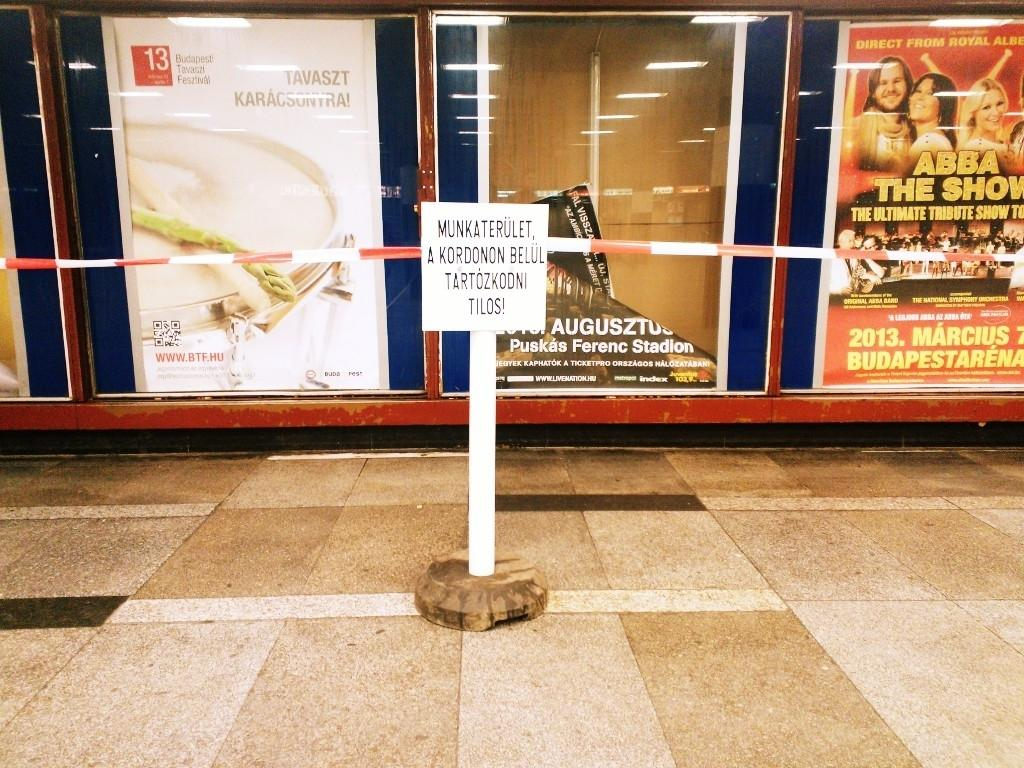<image>
Give a short and clear explanation of the subsequent image. A sign in a foreign language stands in front of an Abba poster. 